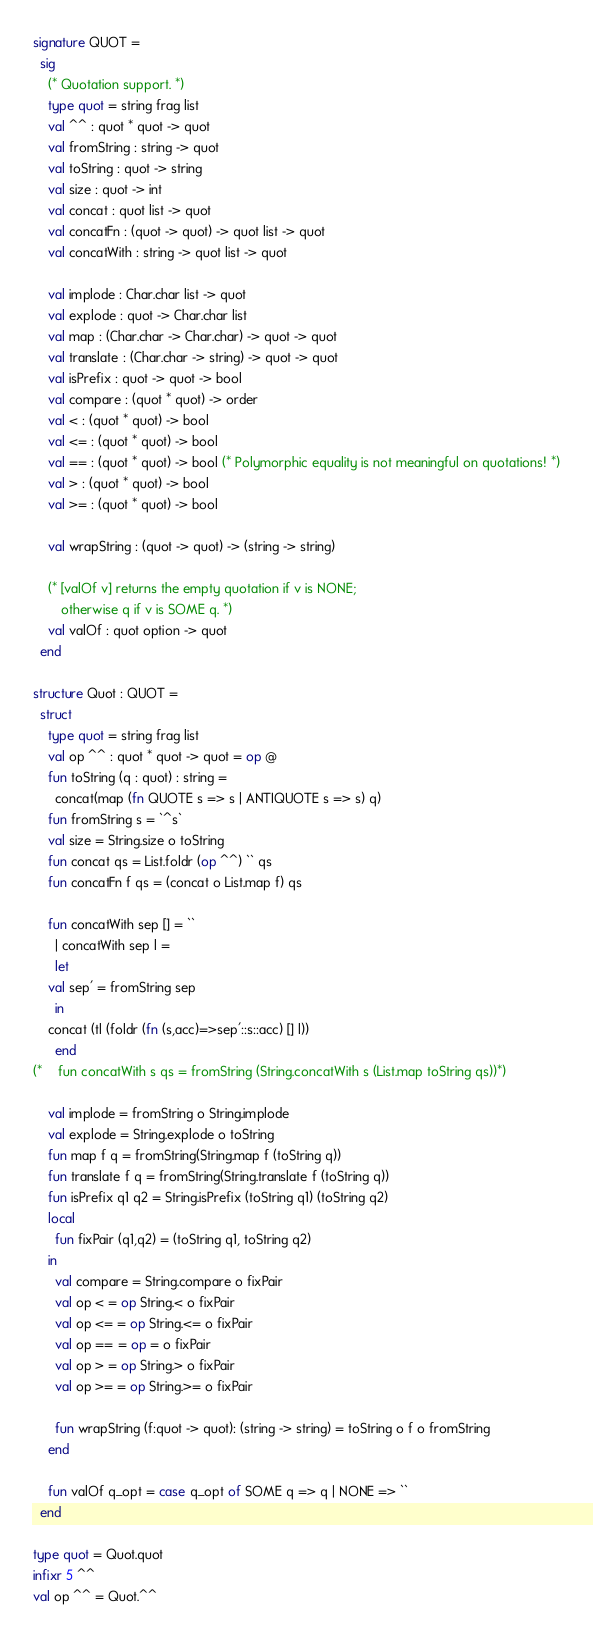<code> <loc_0><loc_0><loc_500><loc_500><_SML_>signature QUOT =
  sig
    (* Quotation support. *)
    type quot = string frag list
    val ^^ : quot * quot -> quot
    val fromString : string -> quot
    val toString : quot -> string 
    val size : quot -> int 
    val concat : quot list -> quot 
    val concatFn : (quot -> quot) -> quot list -> quot
    val concatWith : string -> quot list -> quot

    val implode : Char.char list -> quot
    val explode : quot -> Char.char list 
    val map : (Char.char -> Char.char) -> quot -> quot
    val translate : (Char.char -> string) -> quot -> quot
    val isPrefix : quot -> quot -> bool 
    val compare : (quot * quot) -> order 
    val < : (quot * quot) -> bool 
    val <= : (quot * quot) -> bool 
    val == : (quot * quot) -> bool (* Polymorphic equality is not meaningful on quotations! *)
    val > : (quot * quot) -> bool 
    val >= : (quot * quot) -> bool 

    val wrapString : (quot -> quot) -> (string -> string)

    (* [valOf v] returns the empty quotation if v is NONE;
       otherwise q if v is SOME q. *)
    val valOf : quot option -> quot
  end

structure Quot : QUOT =
  struct
    type quot = string frag list
    val op ^^ : quot * quot -> quot = op @
    fun toString (q : quot) : string =
      concat(map (fn QUOTE s => s | ANTIQUOTE s => s) q)
    fun fromString s = `^s`
    val size = String.size o toString
    fun concat qs = List.foldr (op ^^) `` qs
    fun concatFn f qs = (concat o List.map f) qs

    fun concatWith sep [] = ``
      | concatWith sep l = 
      let
	val sep' = fromString sep
      in
	concat (tl (foldr (fn (s,acc)=>sep'::s::acc) [] l))
      end
(*    fun concatWith s qs = fromString (String.concatWith s (List.map toString qs))*)

    val implode = fromString o String.implode 
    val explode = String.explode o toString
    fun map f q = fromString(String.map f (toString q))
    fun translate f q = fromString(String.translate f (toString q))
    fun isPrefix q1 q2 = String.isPrefix (toString q1) (toString q2)
    local
      fun fixPair (q1,q2) = (toString q1, toString q2)
    in
      val compare = String.compare o fixPair
      val op < = op String.< o fixPair
      val op <= = op String.<= o fixPair
      val op == = op = o fixPair
      val op > = op String.> o fixPair
      val op >= = op String.>= o fixPair

      fun wrapString (f:quot -> quot): (string -> string) = toString o f o fromString 
    end

    fun valOf q_opt = case q_opt of SOME q => q | NONE => ``
  end

type quot = Quot.quot
infixr 5 ^^
val op ^^ = Quot.^^

</code> 